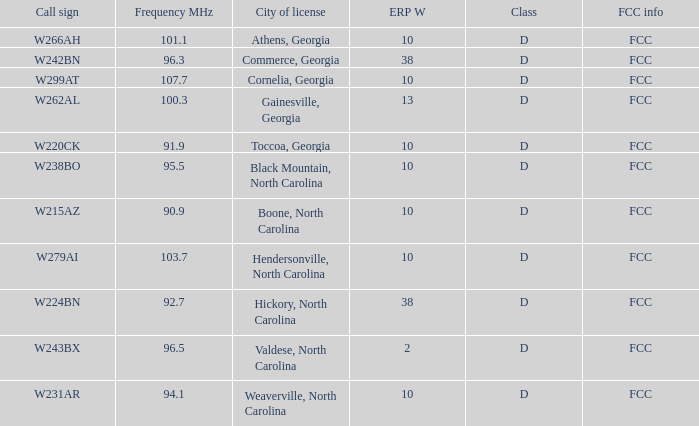What is the mhz frequency for the station with a call sign of w224bn? 92.7. 